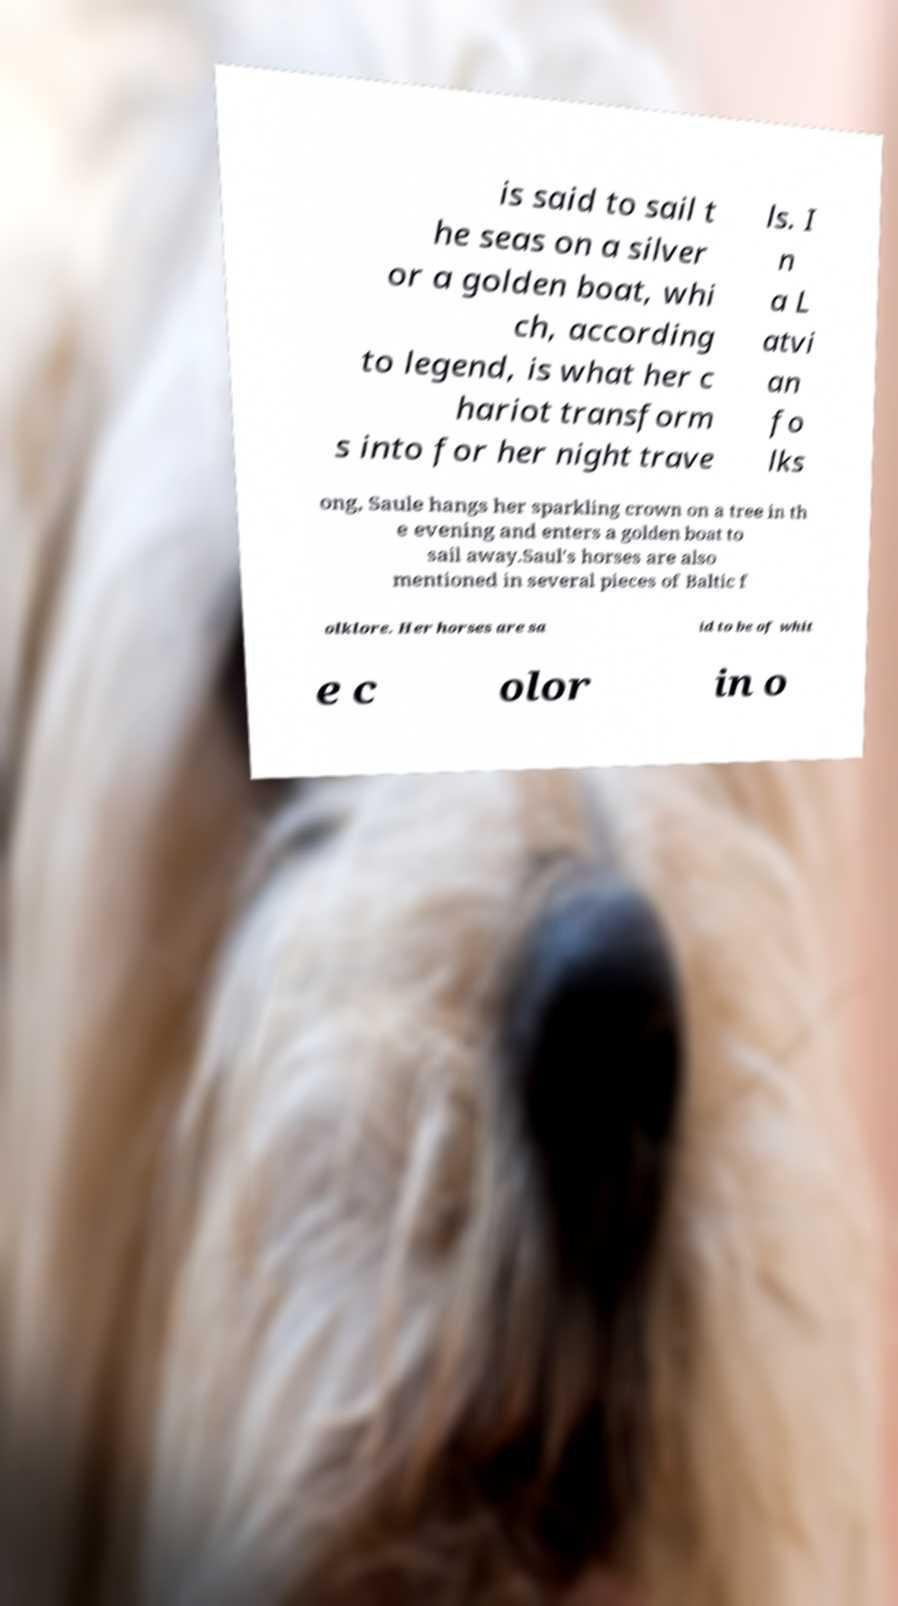What messages or text are displayed in this image? I need them in a readable, typed format. is said to sail t he seas on a silver or a golden boat, whi ch, according to legend, is what her c hariot transform s into for her night trave ls. I n a L atvi an fo lks ong, Saule hangs her sparkling crown on a tree in th e evening and enters a golden boat to sail away.Saul's horses are also mentioned in several pieces of Baltic f olklore. Her horses are sa id to be of whit e c olor in o 